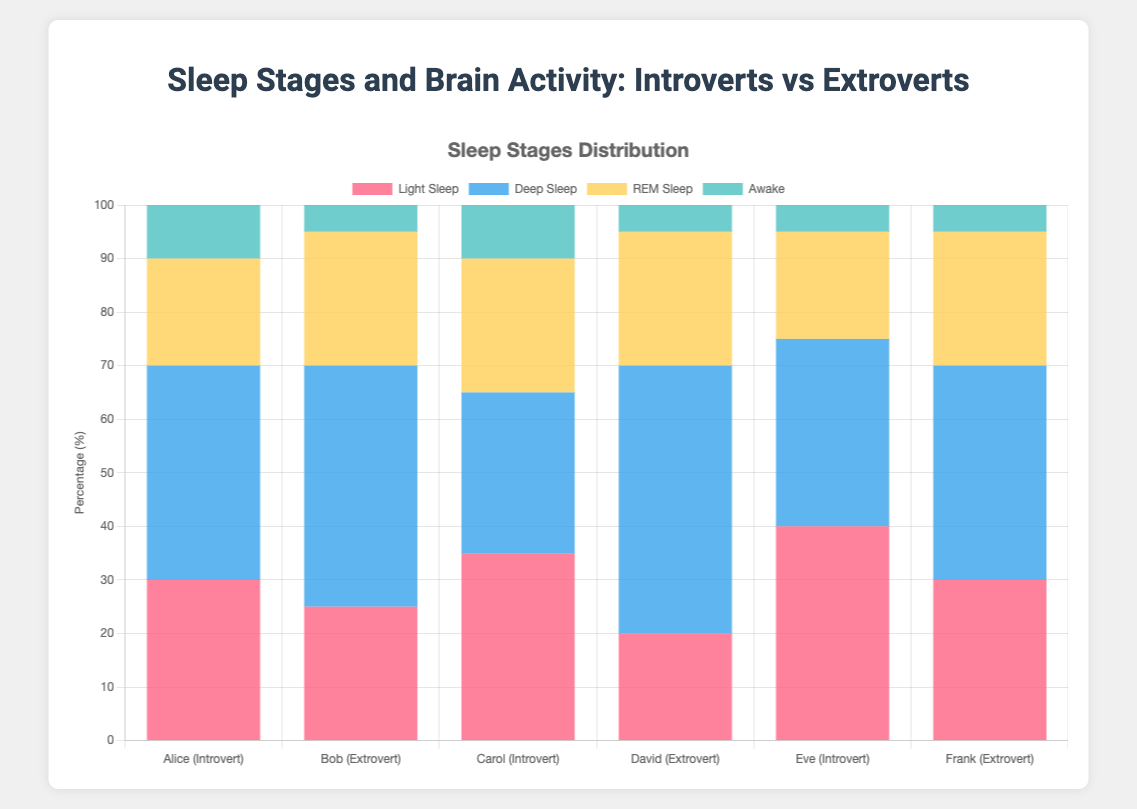What are the total percentages of light sleep for introverts compared to extroverts? Sum the percentages of light sleep for introverts (Alice: 30%, Carol: 35%, Eve: 40%) and then for extroverts (Bob: 25%, David: 20%, Frank: 30%). Total for introverts: 30 + 35 + 40 = 105. Total for extroverts: 25 + 20 + 30 = 75.
Answer: Introverts: 105%, Extroverts: 75% Who spends more time in deep sleep, introverts or extroverts? Sum the percentages of deep sleep for introverts (Alice: 40%, Carol: 30%, Eve: 35%) and then for extroverts (Bob: 45%, David: 50%, Frank: 40%). Total for introverts: 40 + 30 + 35 = 105. Total for extroverts: 45 + 50 + 40 = 135.
Answer: Extroverts Which individual has the highest brain activity during REM sleep? Compare the percentages of brain activity during REM sleep for each participant (Alice: 15%, Bob: 18%, Carol: 14%, David: 19%, Eve: 13%, Frank: 17%). The highest value is David's 19%.
Answer: David In terms of awake time, do introverts or extroverts spend more percentage of time awake overall? Sum the percentages of awake time for introverts (Alice: 10%, Carol: 10%, Eve: 5%) and then for extroverts (Bob: 5%, David: 5%, Frank: 5%). Total for introverts: 10 + 10 + 5 = 25. Total for extroverts: 5 + 5 + 5 = 15.
Answer: Introverts How does the brain activity in deep sleep compare between Alice and Bob? Compare the brain activity percentages in deep sleep for Alice (8%) and Bob (10%). Bob's brain activity in deep sleep is greater than Alice's.
Answer: Bob Are there any participants who spend equal time in deep sleep and REM sleep? Compare the percentages of deep sleep and REM sleep for each participant. No participant has equal percentages in both stages.
Answer: No Who has the lowest brain activity in deep sleep among all participants? Compare the brain activity percentages in deep sleep for all participants (Alice: 8%, Bob: 10%, Carol: 9%, David: 12%, Eve: 7%, Frank: 11%). The lowest value is Eve's 7%.
Answer: Eve 